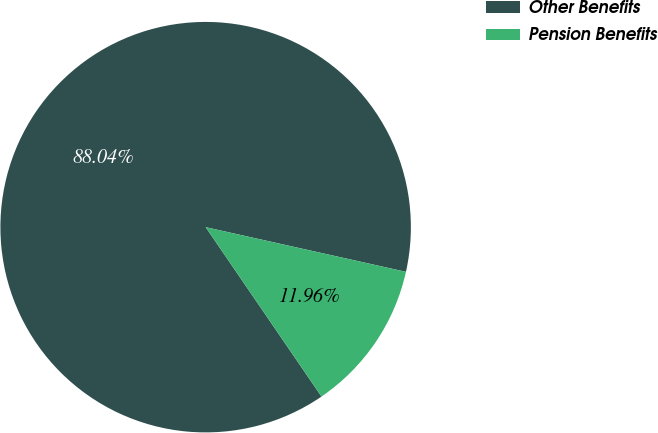Convert chart to OTSL. <chart><loc_0><loc_0><loc_500><loc_500><pie_chart><fcel>Other Benefits<fcel>Pension Benefits<nl><fcel>88.04%<fcel>11.96%<nl></chart> 